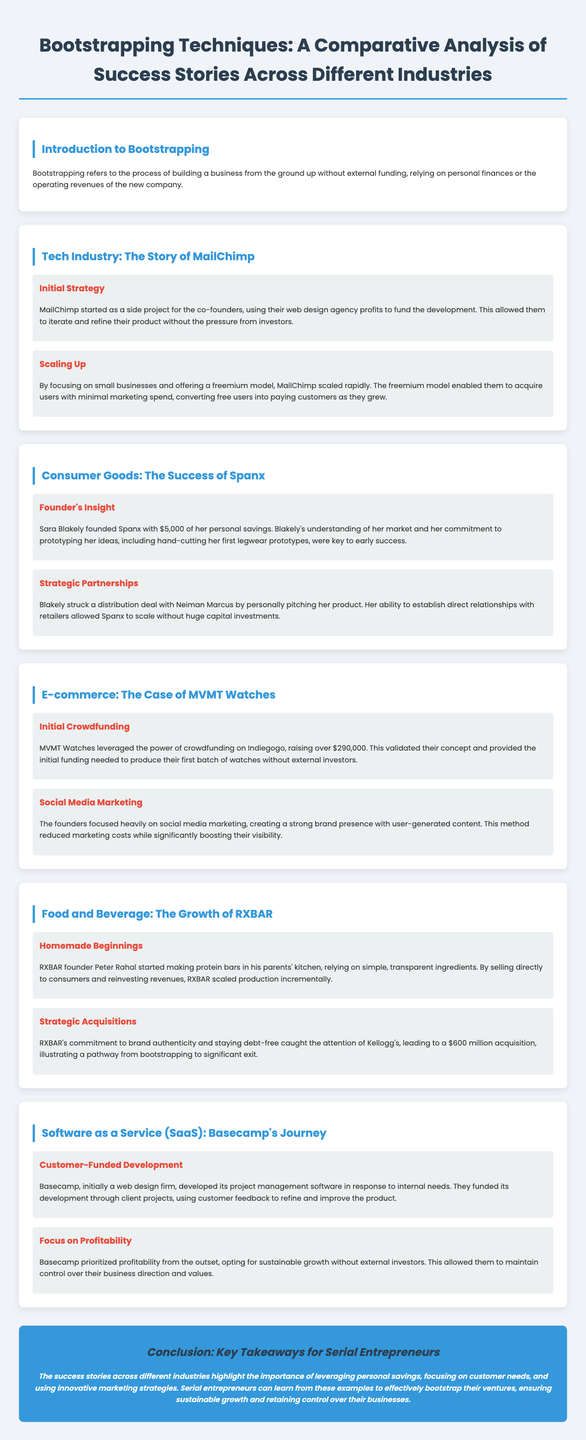What is bootstrapping? Bootstrapping refers to the process of building a business from the ground up without external funding, relying on personal finances or the operating revenues of the new company.
Answer: Building a business without external funding Who is the founder of Spanx? The text identifies Sara Blakely as the founder of Spanx.
Answer: Sara Blakely How much did MVMT Watches raise through crowdfunding? The document states that MVMT Watches raised over $290,000 via Indiegogo.
Answer: $290,000 What was Basecamp originally? The document describes Basecamp as initially a web design firm.
Answer: A web design firm What strategic partnership did Sara Blakely establish? Sara Blakely struck a distribution deal with Neiman Marcus.
Answer: Neiman Marcus What marketing strategy did MailChimp use? MailChimp used a freemium model to acquire users.
Answer: Freemium model What aspect of RXBAR's business caught Kellogg's attention? RXBAR's commitment to brand authenticity and staying debt-free attracted Kellogg's interest.
Answer: Brand authenticity and staying debt-free How did Basecamp fund its project management software? They funded its development through client projects.
Answer: Through client projects 